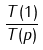Convert formula to latex. <formula><loc_0><loc_0><loc_500><loc_500>\frac { T ( 1 ) } { T ( p ) }</formula> 